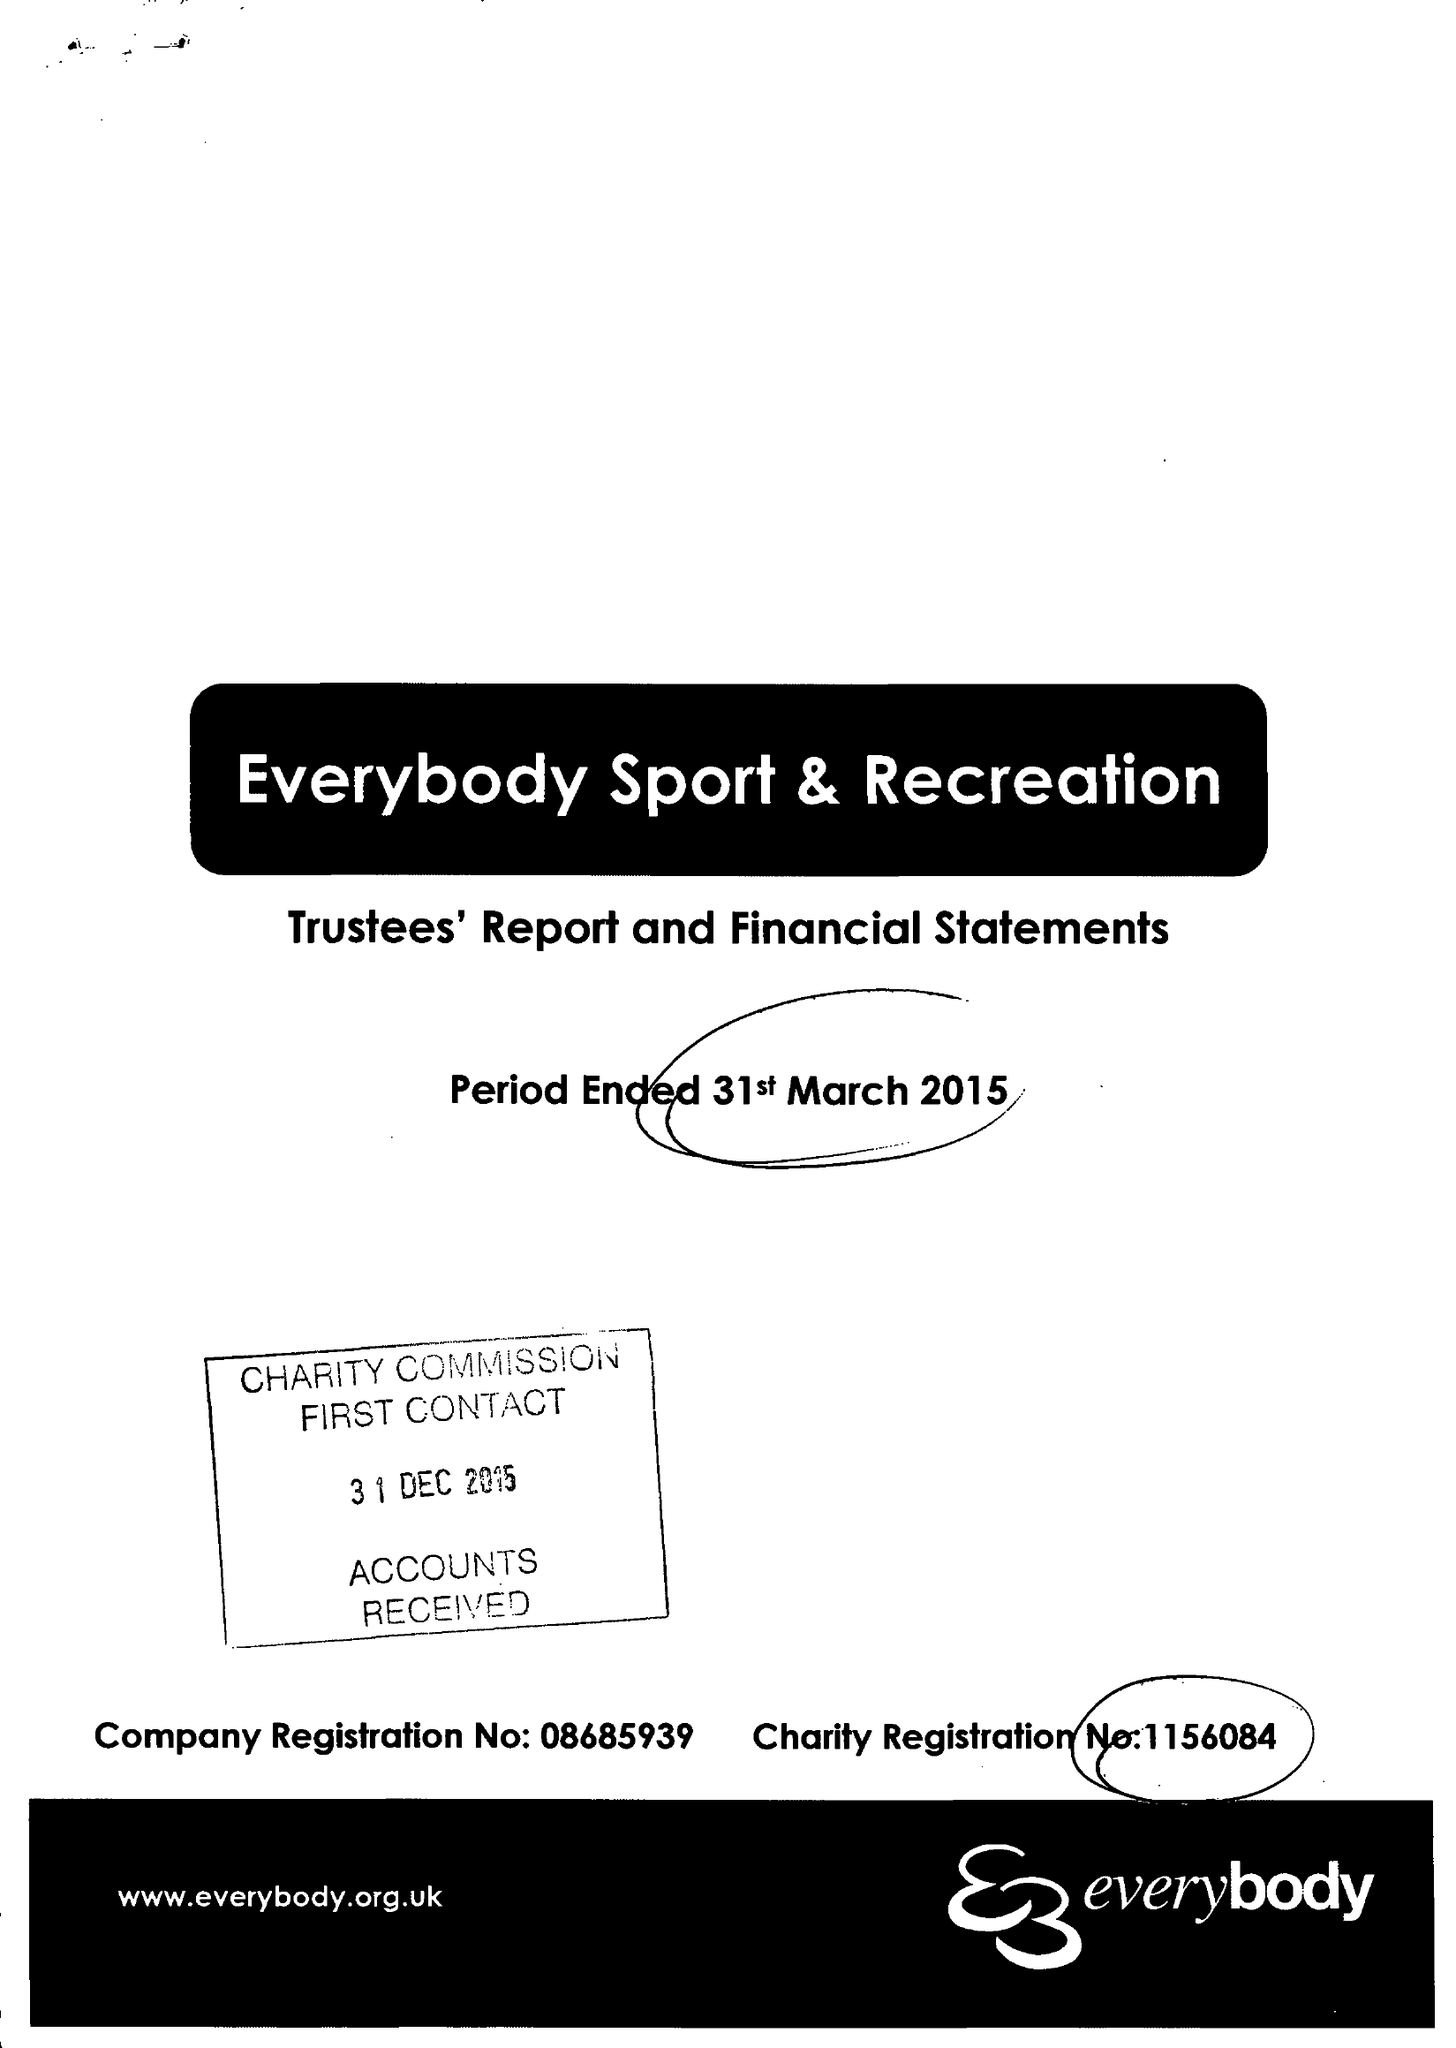What is the value for the report_date?
Answer the question using a single word or phrase. 2015-03-31 